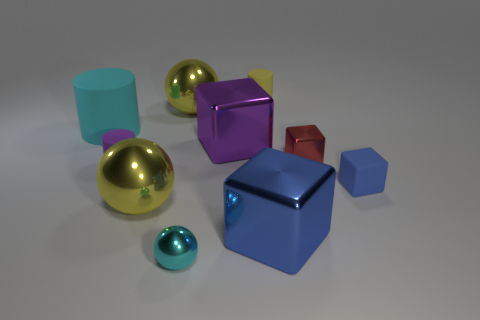Subtract all spheres. How many objects are left? 7 Add 1 cyan things. How many cyan things exist? 3 Subtract 0 green blocks. How many objects are left? 10 Subtract all large brown metal cylinders. Subtract all yellow objects. How many objects are left? 7 Add 6 blue metal objects. How many blue metal objects are left? 7 